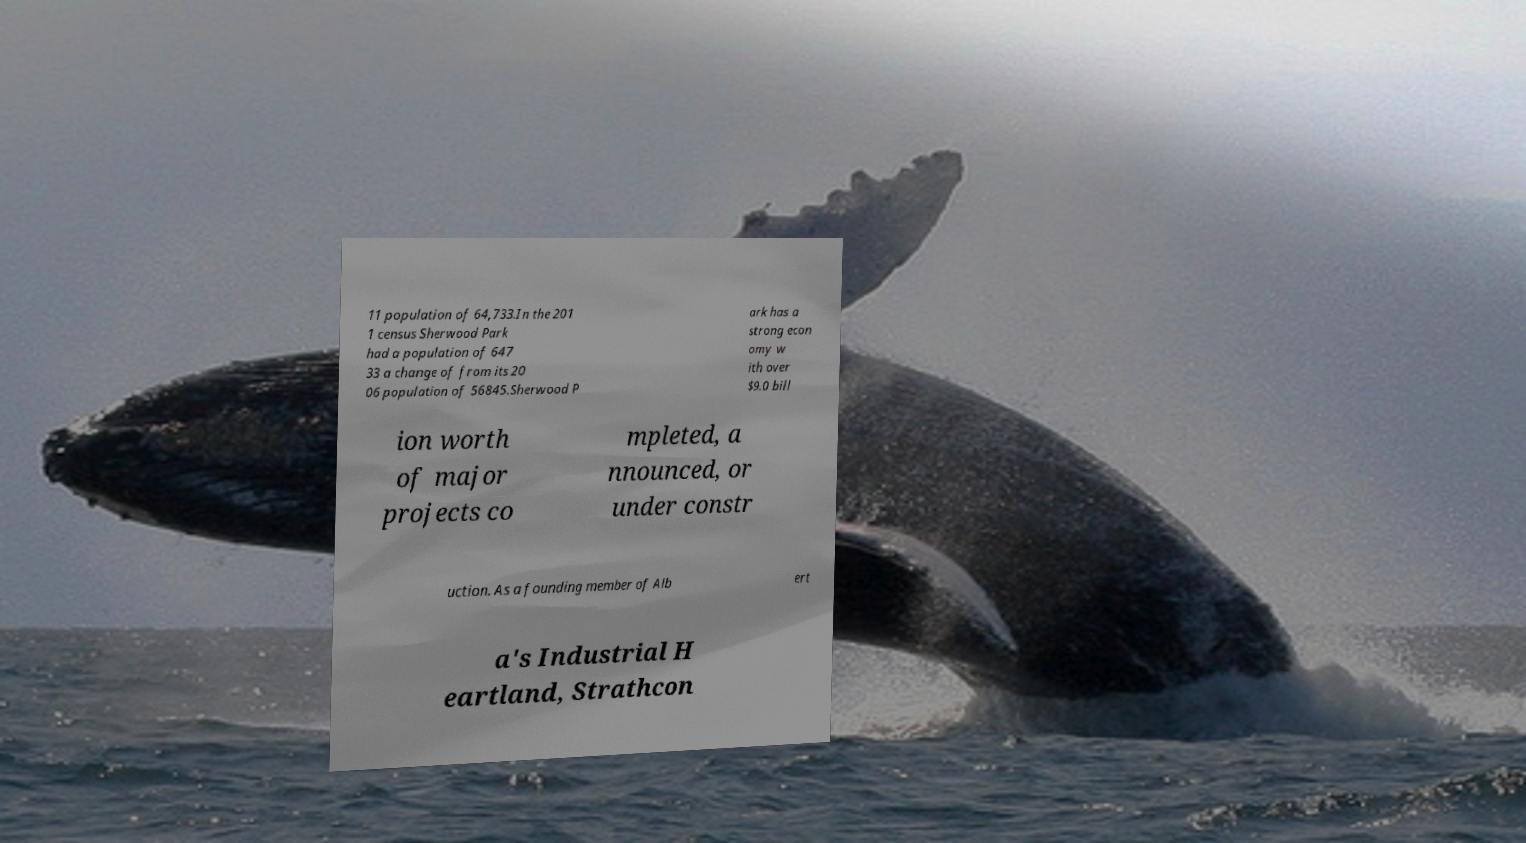I need the written content from this picture converted into text. Can you do that? 11 population of 64,733.In the 201 1 census Sherwood Park had a population of 647 33 a change of from its 20 06 population of 56845.Sherwood P ark has a strong econ omy w ith over $9.0 bill ion worth of major projects co mpleted, a nnounced, or under constr uction. As a founding member of Alb ert a's Industrial H eartland, Strathcon 